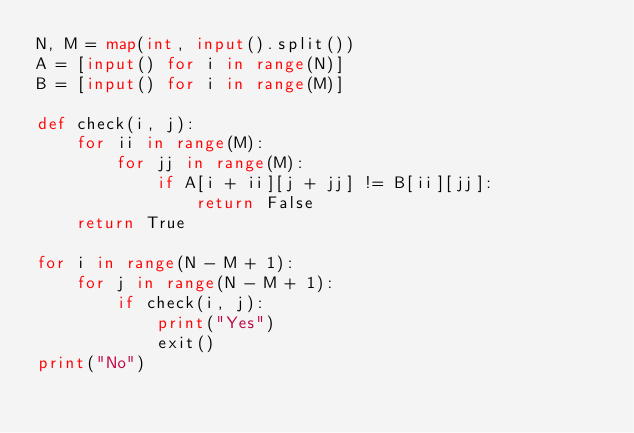<code> <loc_0><loc_0><loc_500><loc_500><_Python_>N, M = map(int, input().split())
A = [input() for i in range(N)]
B = [input() for i in range(M)]

def check(i, j):
    for ii in range(M):
        for jj in range(M):
            if A[i + ii][j + jj] != B[ii][jj]:
                return False
    return True

for i in range(N - M + 1):
    for j in range(N - M + 1):
        if check(i, j):
            print("Yes")
            exit()
print("No")
</code> 